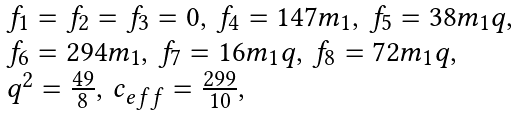<formula> <loc_0><loc_0><loc_500><loc_500>\begin{array} { l } f _ { 1 } = f _ { 2 } = f _ { 3 } = 0 , \, f _ { 4 } = 1 4 7 m _ { 1 } , \, f _ { 5 } = 3 8 m _ { 1 } q , \\ f _ { 6 } = 2 9 4 m _ { 1 } , \, f _ { 7 } = 1 6 m _ { 1 } q , \, f _ { 8 } = 7 2 m _ { 1 } q , \\ q ^ { 2 } = \frac { 4 9 } { 8 } , \, c _ { e f f } = \frac { 2 9 9 } { 1 0 } , \end{array}</formula> 